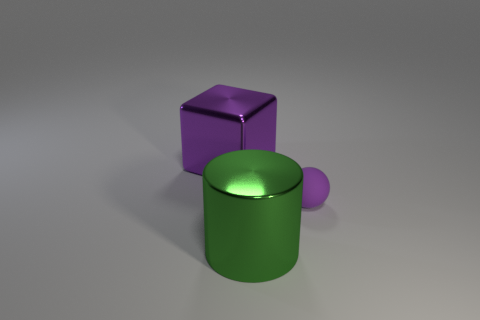There is a thing that is both behind the green object and in front of the purple cube; what is it made of? The object situated between the green cylinder and the purple cube appears to be a small sphere. Based on the image, it is difficult to ascertain the exact material of the sphere with certainty, but given the lighting and reflections, it could be supposed to be made of a similar plastic or matte-finished substance like the other objects in the scene. 